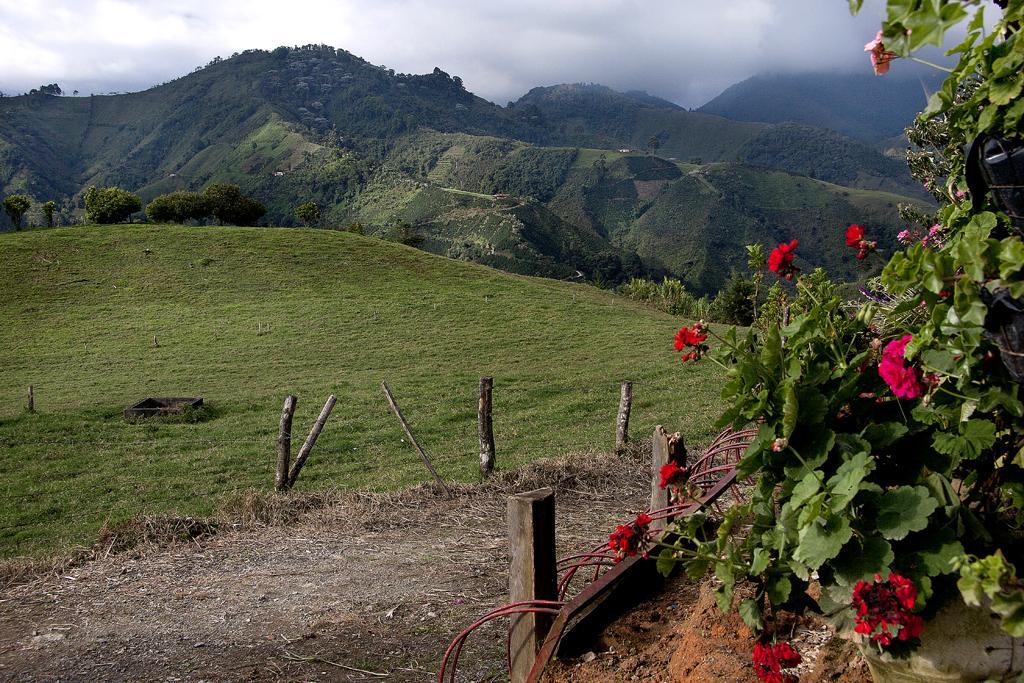Please provide a concise description of this image. In the image we can see the flower plants, wooden poles, and grass. Here we can see hills, trees, smoke and the sky. 